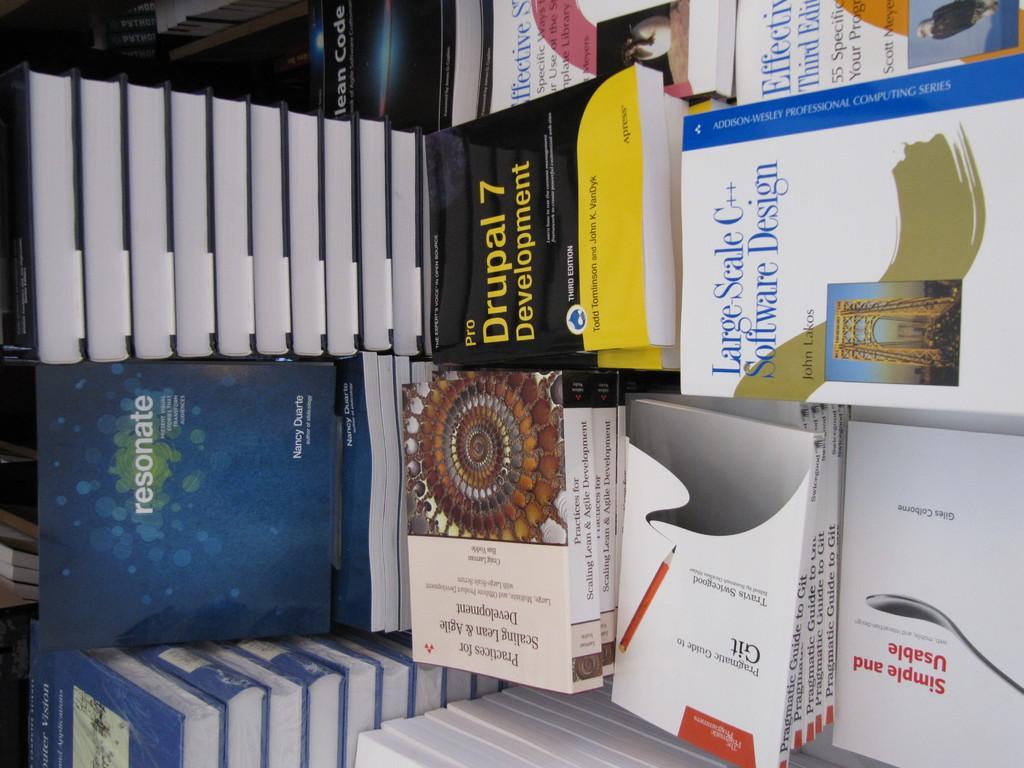Could you give a brief overview of what you see in this image? In this image we can see group of books placed on the surface. 